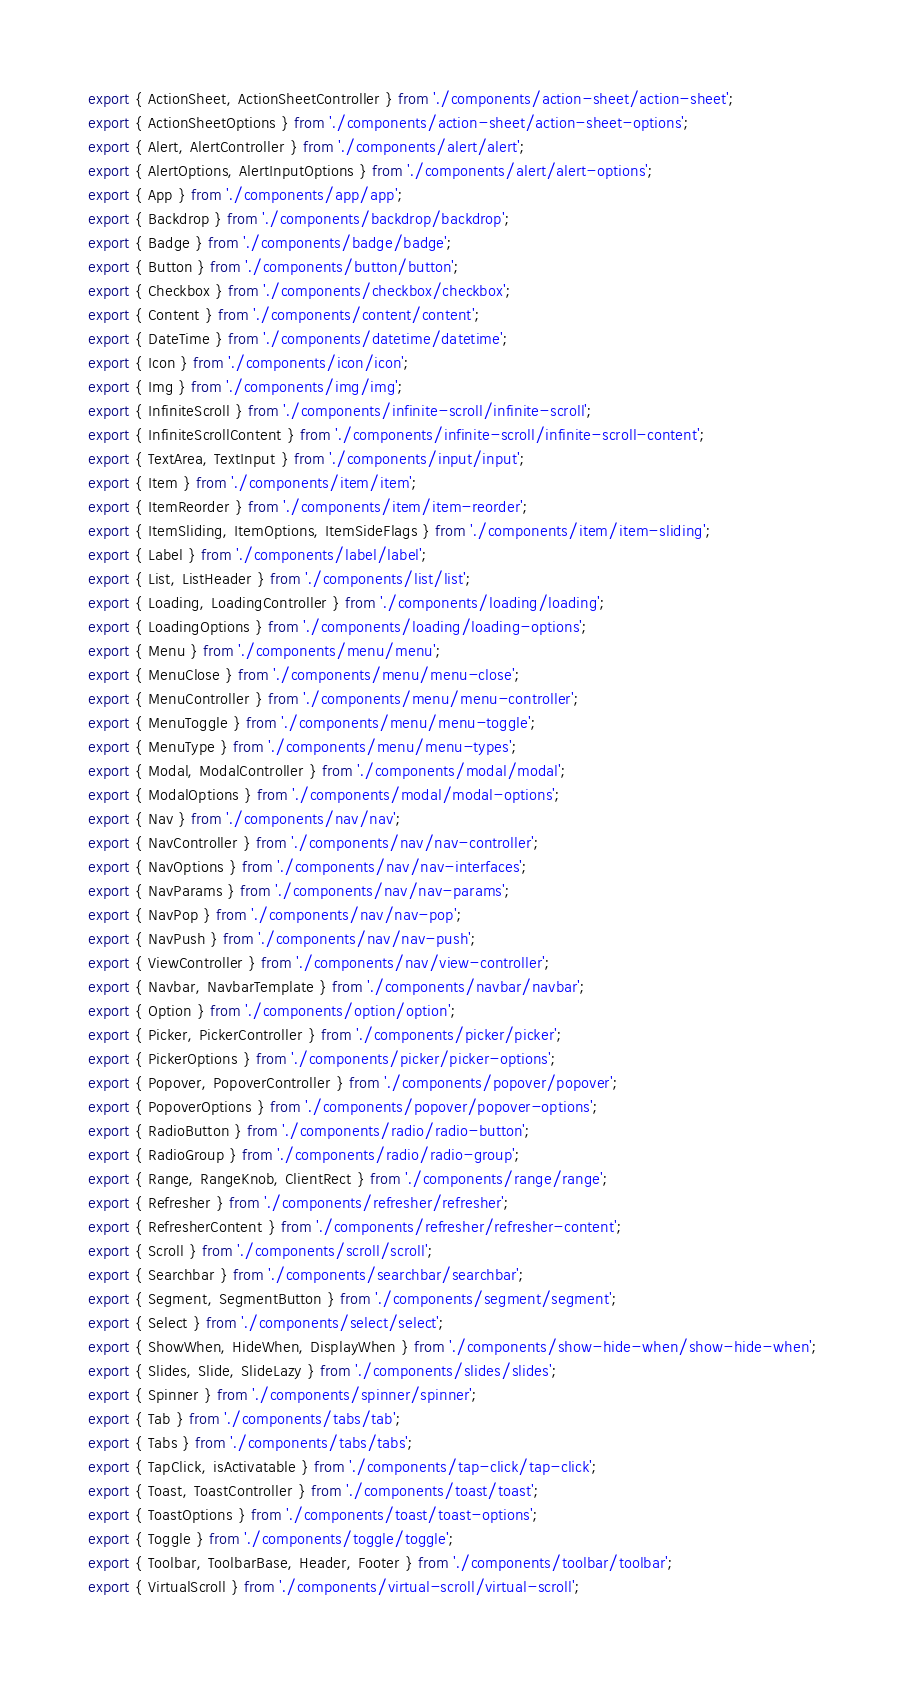<code> <loc_0><loc_0><loc_500><loc_500><_TypeScript_>export { ActionSheet, ActionSheetController } from './components/action-sheet/action-sheet';
export { ActionSheetOptions } from './components/action-sheet/action-sheet-options';
export { Alert, AlertController } from './components/alert/alert';
export { AlertOptions, AlertInputOptions } from './components/alert/alert-options';
export { App } from './components/app/app';
export { Backdrop } from './components/backdrop/backdrop';
export { Badge } from './components/badge/badge';
export { Button } from './components/button/button';
export { Checkbox } from './components/checkbox/checkbox';
export { Content } from './components/content/content';
export { DateTime } from './components/datetime/datetime';
export { Icon } from './components/icon/icon';
export { Img } from './components/img/img';
export { InfiniteScroll } from './components/infinite-scroll/infinite-scroll';
export { InfiniteScrollContent } from './components/infinite-scroll/infinite-scroll-content';
export { TextArea, TextInput } from './components/input/input';
export { Item } from './components/item/item';
export { ItemReorder } from './components/item/item-reorder';
export { ItemSliding, ItemOptions, ItemSideFlags } from './components/item/item-sliding';
export { Label } from './components/label/label';
export { List, ListHeader } from './components/list/list';
export { Loading, LoadingController } from './components/loading/loading';
export { LoadingOptions } from './components/loading/loading-options';
export { Menu } from './components/menu/menu';
export { MenuClose } from './components/menu/menu-close';
export { MenuController } from './components/menu/menu-controller';
export { MenuToggle } from './components/menu/menu-toggle';
export { MenuType } from './components/menu/menu-types';
export { Modal, ModalController } from './components/modal/modal';
export { ModalOptions } from './components/modal/modal-options';
export { Nav } from './components/nav/nav';
export { NavController } from './components/nav/nav-controller';
export { NavOptions } from './components/nav/nav-interfaces';
export { NavParams } from './components/nav/nav-params';
export { NavPop } from './components/nav/nav-pop';
export { NavPush } from './components/nav/nav-push';
export { ViewController } from './components/nav/view-controller';
export { Navbar, NavbarTemplate } from './components/navbar/navbar';
export { Option } from './components/option/option';
export { Picker, PickerController } from './components/picker/picker';
export { PickerOptions } from './components/picker/picker-options';
export { Popover, PopoverController } from './components/popover/popover';
export { PopoverOptions } from './components/popover/popover-options';
export { RadioButton } from './components/radio/radio-button';
export { RadioGroup } from './components/radio/radio-group';
export { Range, RangeKnob, ClientRect } from './components/range/range';
export { Refresher } from './components/refresher/refresher';
export { RefresherContent } from './components/refresher/refresher-content';
export { Scroll } from './components/scroll/scroll';
export { Searchbar } from './components/searchbar/searchbar';
export { Segment, SegmentButton } from './components/segment/segment';
export { Select } from './components/select/select';
export { ShowWhen, HideWhen, DisplayWhen } from './components/show-hide-when/show-hide-when';
export { Slides, Slide, SlideLazy } from './components/slides/slides';
export { Spinner } from './components/spinner/spinner';
export { Tab } from './components/tabs/tab';
export { Tabs } from './components/tabs/tabs';
export { TapClick, isActivatable } from './components/tap-click/tap-click';
export { Toast, ToastController } from './components/toast/toast';
export { ToastOptions } from './components/toast/toast-options';
export { Toggle } from './components/toggle/toggle';
export { Toolbar, ToolbarBase, Header, Footer } from './components/toolbar/toolbar';
export { VirtualScroll } from './components/virtual-scroll/virtual-scroll';
</code> 